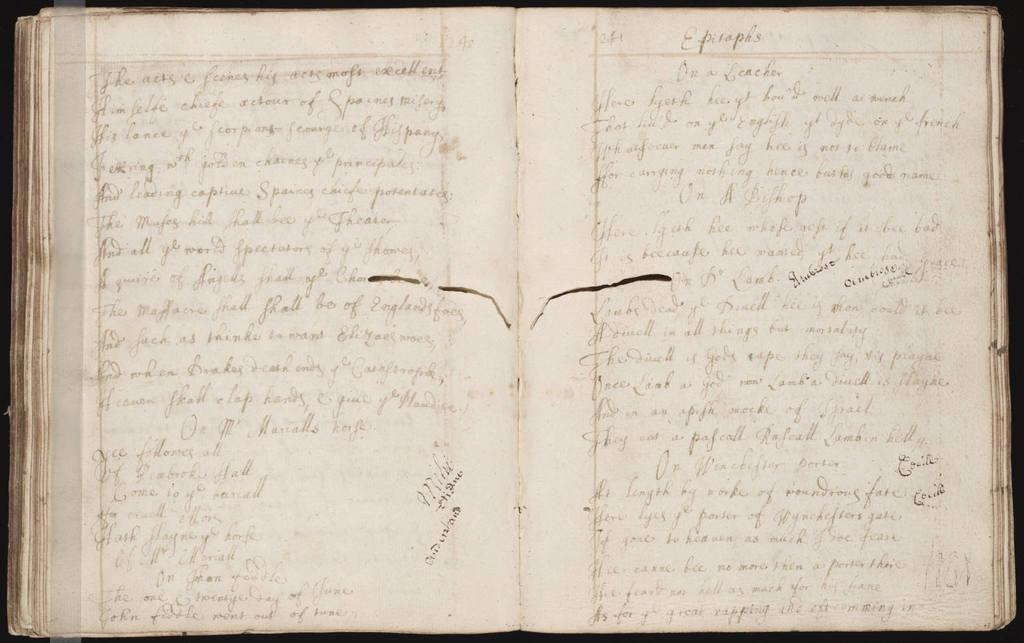What is the main object in the image? There is an open book in the image. What can be seen on the pages of the open book? There is text visible on the open book. How many trucks are parked next to the book in the image? There are no trucks present in the image; it only features an open book with text. 